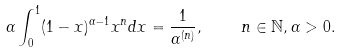<formula> <loc_0><loc_0><loc_500><loc_500>\alpha \int _ { 0 } ^ { 1 } ( 1 - x ) ^ { \alpha - 1 } x ^ { n } d x = \frac { 1 } { \alpha ^ { ( n ) } } , \quad n \in \mathbb { N } , \alpha > 0 .</formula> 